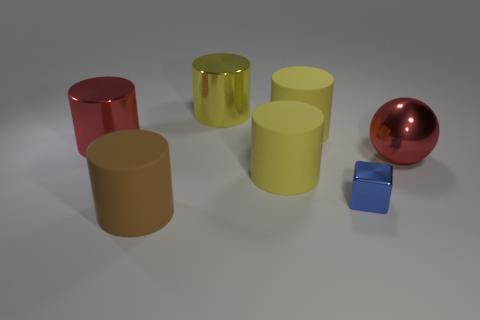There is a shiny cylinder that is right of the brown matte object; is its size the same as the red thing to the left of the large brown cylinder?
Your answer should be compact. Yes. How many cubes are either small things or big brown rubber objects?
Keep it short and to the point. 1. How many shiny things are small gray cubes or big red balls?
Offer a very short reply. 1. There is a yellow shiny object that is the same shape as the brown matte object; what is its size?
Ensure brevity in your answer.  Large. Are there any other things that have the same size as the brown rubber thing?
Keep it short and to the point. Yes. There is a blue object; is its size the same as the yellow matte cylinder that is behind the big red cylinder?
Make the answer very short. No. There is a large red thing that is behind the big red sphere; what is its shape?
Offer a very short reply. Cylinder. What color is the big metal cylinder behind the red metal object on the left side of the blue cube?
Provide a succinct answer. Yellow. What color is the other big shiny object that is the same shape as the large yellow metal thing?
Provide a succinct answer. Red. How many cylinders are the same color as the large shiny sphere?
Ensure brevity in your answer.  1. 